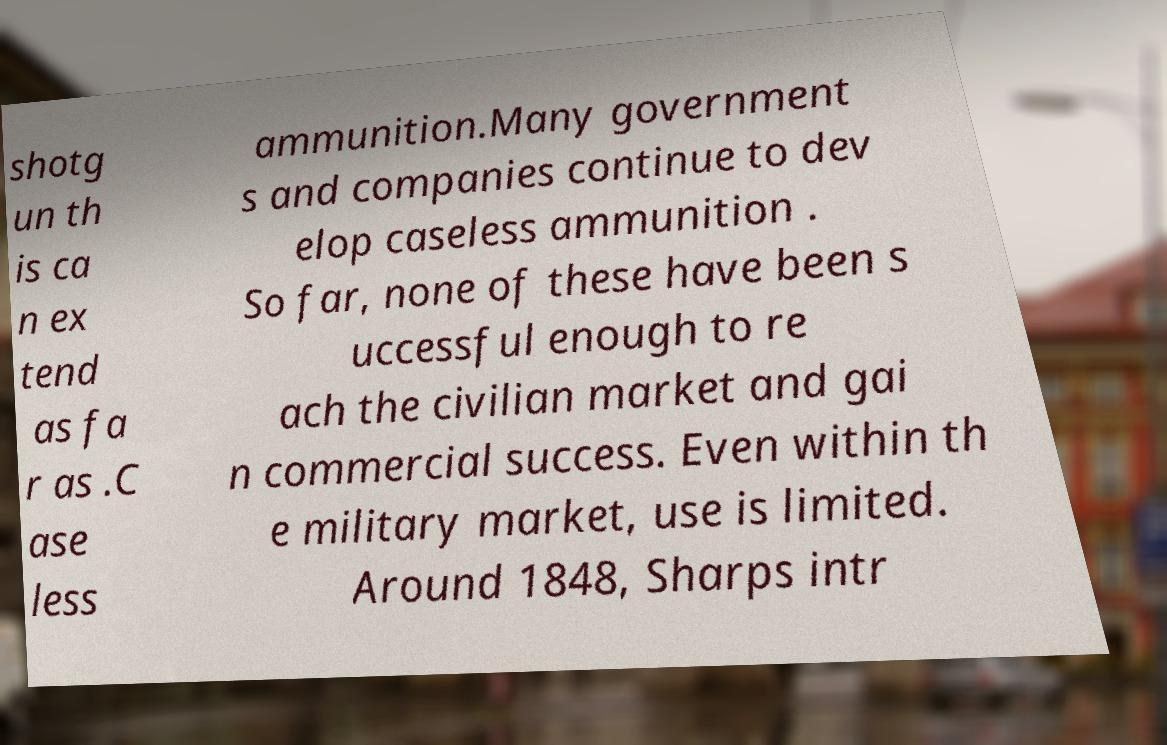There's text embedded in this image that I need extracted. Can you transcribe it verbatim? shotg un th is ca n ex tend as fa r as .C ase less ammunition.Many government s and companies continue to dev elop caseless ammunition . So far, none of these have been s uccessful enough to re ach the civilian market and gai n commercial success. Even within th e military market, use is limited. Around 1848, Sharps intr 